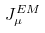<formula> <loc_0><loc_0><loc_500><loc_500>J _ { \mu } ^ { E M }</formula> 